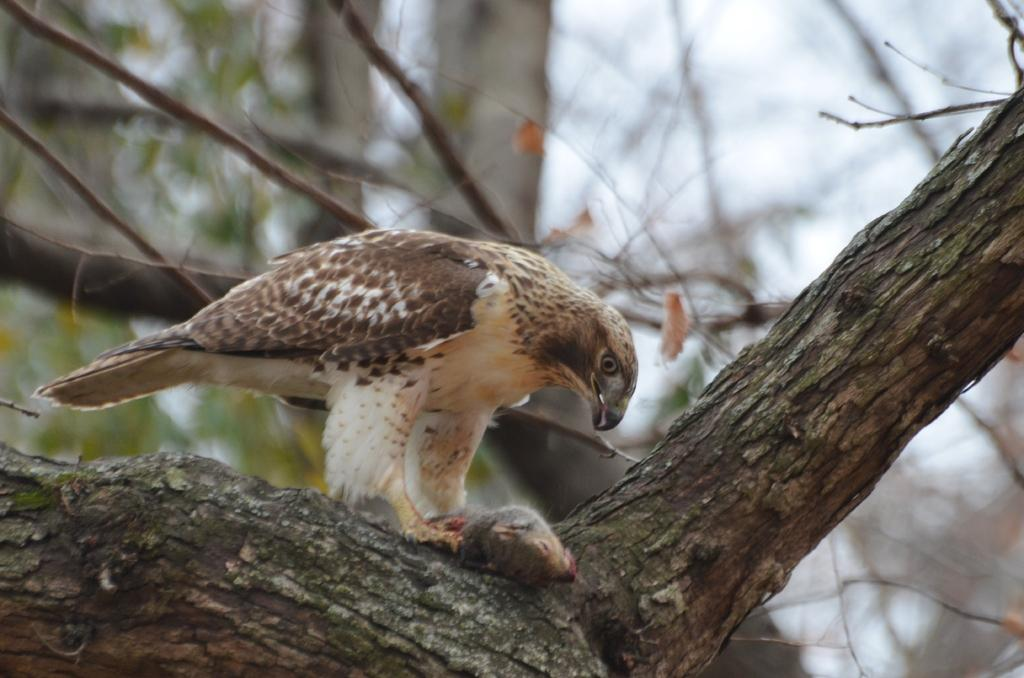What type of animal can be seen in the image? There is a bird in the image. Where is the bird located? The bird is on a tree. What can be seen in the background of the image? There are leaves visible in the background of the image. What type of behavior does the bird exhibit towards the ray in the image? There is no ray present in the image, so the bird's behavior towards a ray cannot be determined. 